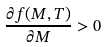<formula> <loc_0><loc_0><loc_500><loc_500>\frac { \partial f ( M , T ) } { \partial M } > 0</formula> 